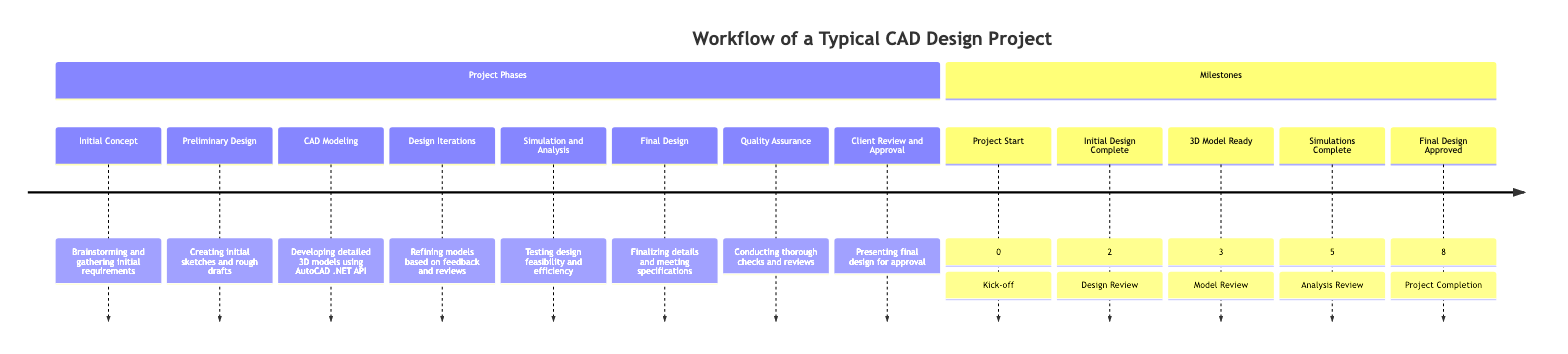What is the first step in the CAD Design Project Workflow? The first step in the timeline is labeled "Initial Concept", which involves brainstorming and gathering initial requirements from the client, making it the starting point of the workflow.
Answer: Initial Concept How many steps are in the CAD Design Project Workflow? By counting the list of steps in the timeline, we find that there are eight distinct steps in total, each with its own specific function in the process.
Answer: 8 What step follows the Design Iterations? Looking closely at the sequence of steps, "Simulation and Analysis" comes directly after "Design Iterations", indicating the progression from refining designs to testing their feasibility.
Answer: Simulation and Analysis What is the main activity during the CAD Modeling step? The description of the "CAD Modeling" step specifies that it involves "Developing detailed 3D models using AutoCAD .NET API", which clearly outlines the focus of this phase in the project.
Answer: Developing detailed 3D models using AutoCAD .NET API At what milestone is the Final Design approved? In the "Milestones" section, the milestone for the "Final Design Approved" is positioned at step 8, indicating that this step is crucial for completing the project.
Answer: 8 Which step includes client feedback? Referring to the "Design Iterations" step in the timeline, it states "Refining models based on feedback and reviews," highlighting that client feedback plays a critical role in this phase.
Answer: Design Iterations What is the last step of the workflow? The last step in the workflow is "Client Review and Approval", which indicates that the final design is presented to the client for their approval before the project is concluded.
Answer: Client Review and Approval What is the purpose of Quality Assurance? According to the description in the timeline, "Quality Assurance" consists of conducting thorough checks and reviews, serving the purpose of ensuring that the design meets quality standards.
Answer: Conducting thorough checks and reviews 